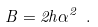<formula> <loc_0><loc_0><loc_500><loc_500>B = 2 h \alpha ^ { 2 } \ .</formula> 